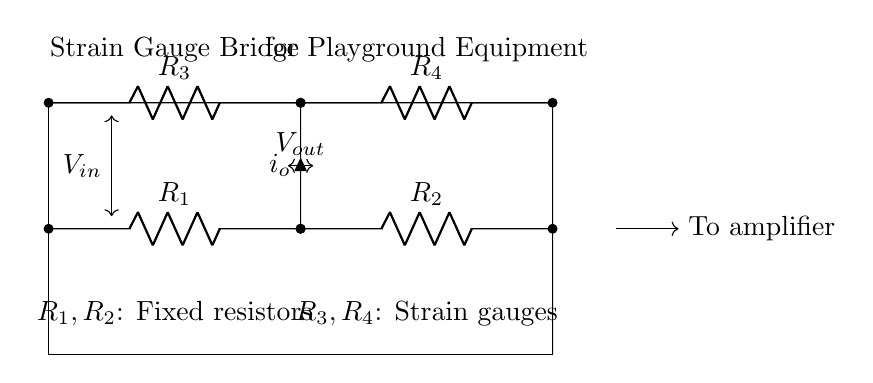What is the type of this circuit? The circuit is a strain gauge bridge circuit, which is used to detect changes in resistance due to applied stress or strain. It forms a bridge configuration connecting resistive elements, allowing for measurement of small variations in voltage.
Answer: strain gauge bridge How many resistors are in the circuit? The circuit consists of four resistors, labelled as R1, R2, R3, and R4. All are arranged in a bridge configuration, with R3 and R4 being the strain gauges and R1, R2 as fixed resistors.
Answer: four What is the role of R3 and R4? Resistors R3 and R4 are strain gauges, which change their resistance in response to mechanical strain, enabling the circuit to monitor the structural integrity of the playground equipment.
Answer: strain gauges What is the output voltage indicated in the circuit? The output voltage, denoted as Vout, is the voltage difference measured across the bridge circuit between the upper and lower resistors. It is used to detect changes caused by strain from R3 and R4.
Answer: Vout What does Io represent in the circuit? Io represents the output current flowing through the bridge, indicating the level of strain detected by the arrangement of resistors, which is directly related to the deformation experienced by either R3 or R4.
Answer: output current Which resistors are fixed, and which are variable? R1 and R2 are the fixed resistors, while R3 and R4 are variable resistors, as they change their resistance under strain conditions, thus impacting the overall balance of the bridge circuit.
Answer: R1, R2: fixed; R3, R4: variable What do you need to do with the output signal? The output signal Vout needs to be processed by an amplifier to enhance its strength for further analysis and to obtain a clearer readout of the structural integrity being monitored.
Answer: To amplifier 